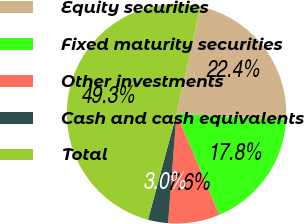<chart> <loc_0><loc_0><loc_500><loc_500><pie_chart><fcel>Equity securities<fcel>Fixed maturity securities<fcel>Other investments<fcel>Cash and cash equivalents<fcel>Total<nl><fcel>22.39%<fcel>17.75%<fcel>7.59%<fcel>2.96%<fcel>49.31%<nl></chart> 